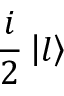Convert formula to latex. <formula><loc_0><loc_0><loc_500><loc_500>\frac { i } { 2 } \left | l \right \rangle</formula> 